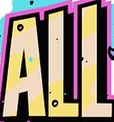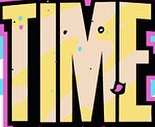What words are shown in these images in order, separated by a semicolon? ALL; TIME 